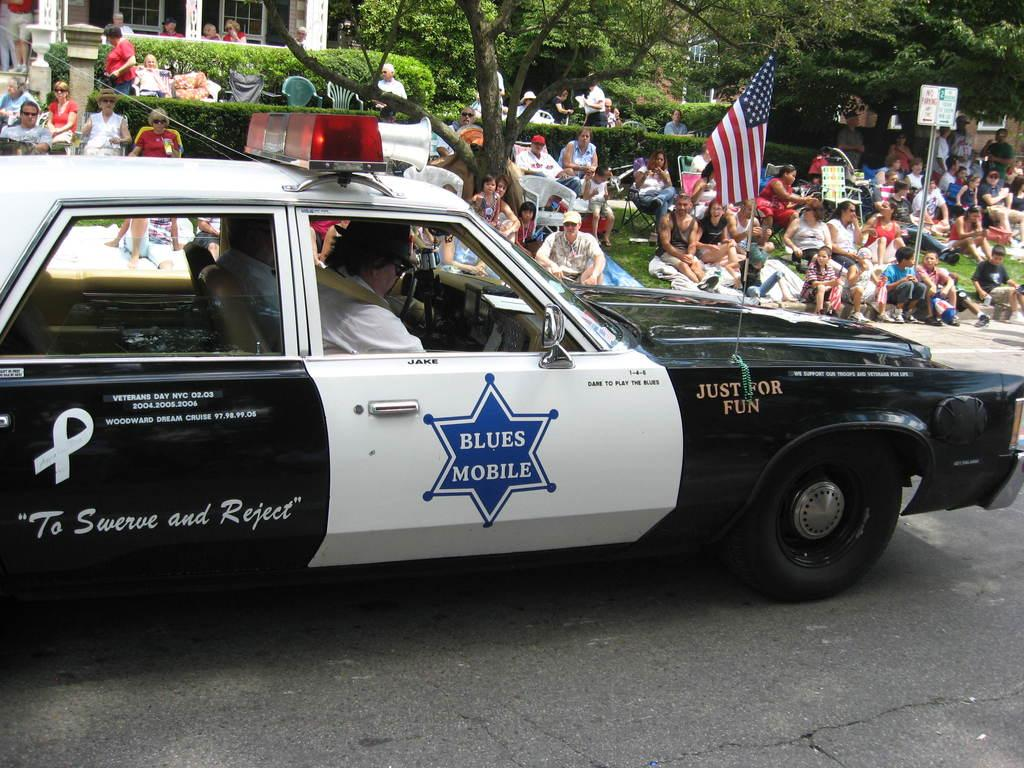What are the people in the image doing? There is a group of people sitting on the ground. What else can be seen in the image besides the people? There is a car on the road. What type of fruit is being carried by the cow in the image? There is no cow or fruit present in the image. How many horses are pulling the carriage in the image? There is no carriage or horses present in the image. 